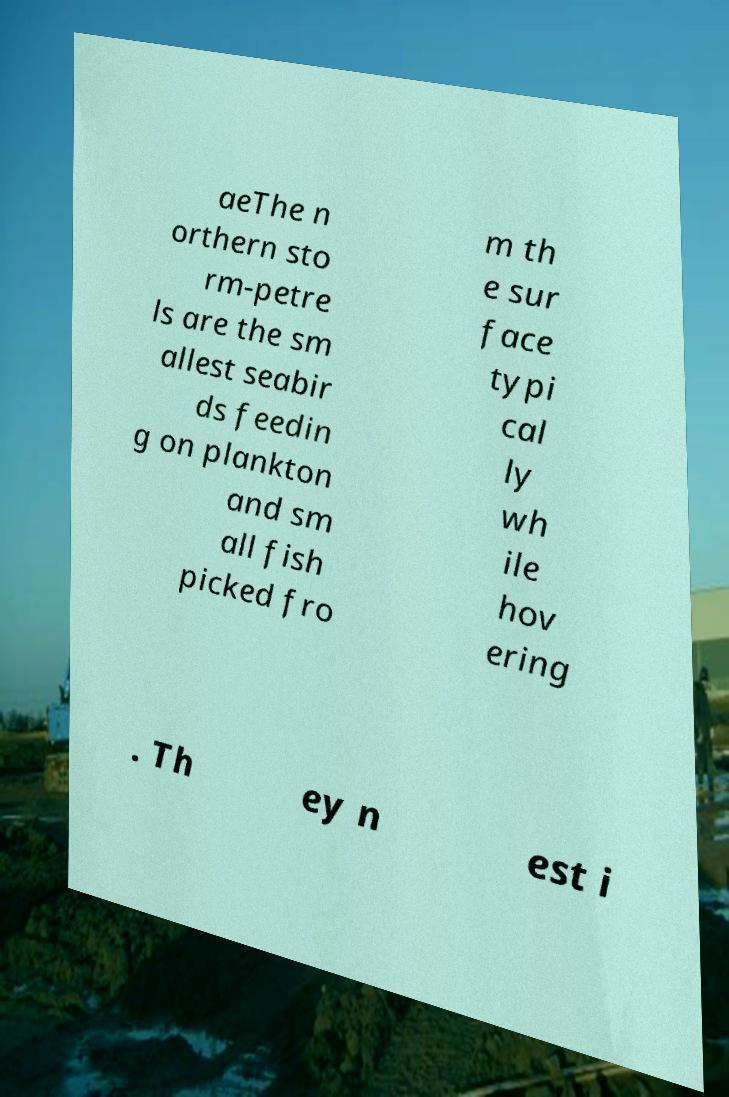Please identify and transcribe the text found in this image. aeThe n orthern sto rm-petre ls are the sm allest seabir ds feedin g on plankton and sm all fish picked fro m th e sur face typi cal ly wh ile hov ering . Th ey n est i 